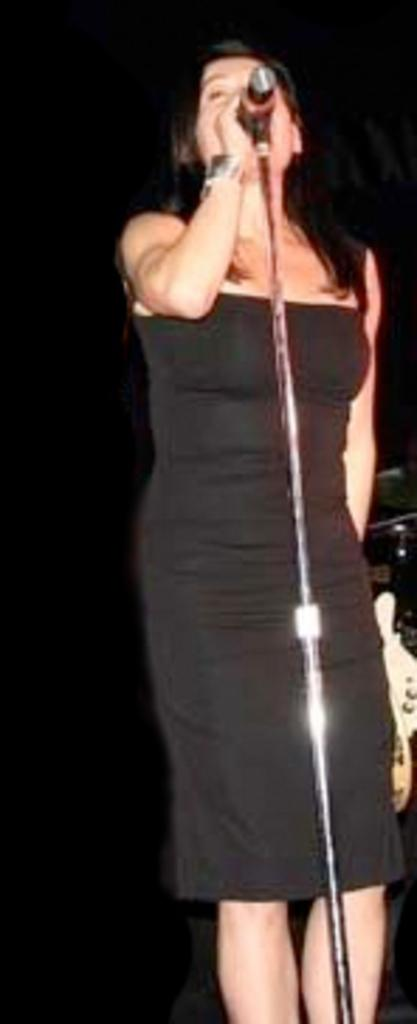Who is the main subject in the image? There is a woman in the image. What is the woman wearing? The woman is wearing a black dress. What is the woman doing in the image? The woman is standing and singing. What object is in front of the woman? There is a microphone in front of the woman. What type of plastic material can be seen in the woman's teeth in the image? There is no plastic material visible in the woman's teeth in the image, and her teeth are not mentioned in the provided facts. What might surprise the woman in the image? The provided facts do not give any information about what might surprise the woman in the image. 